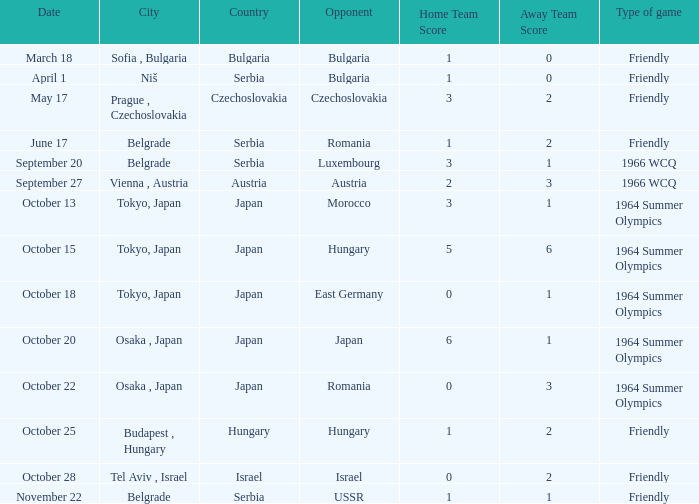Wjich city had a date of october 13? Tokyo, Japan. 